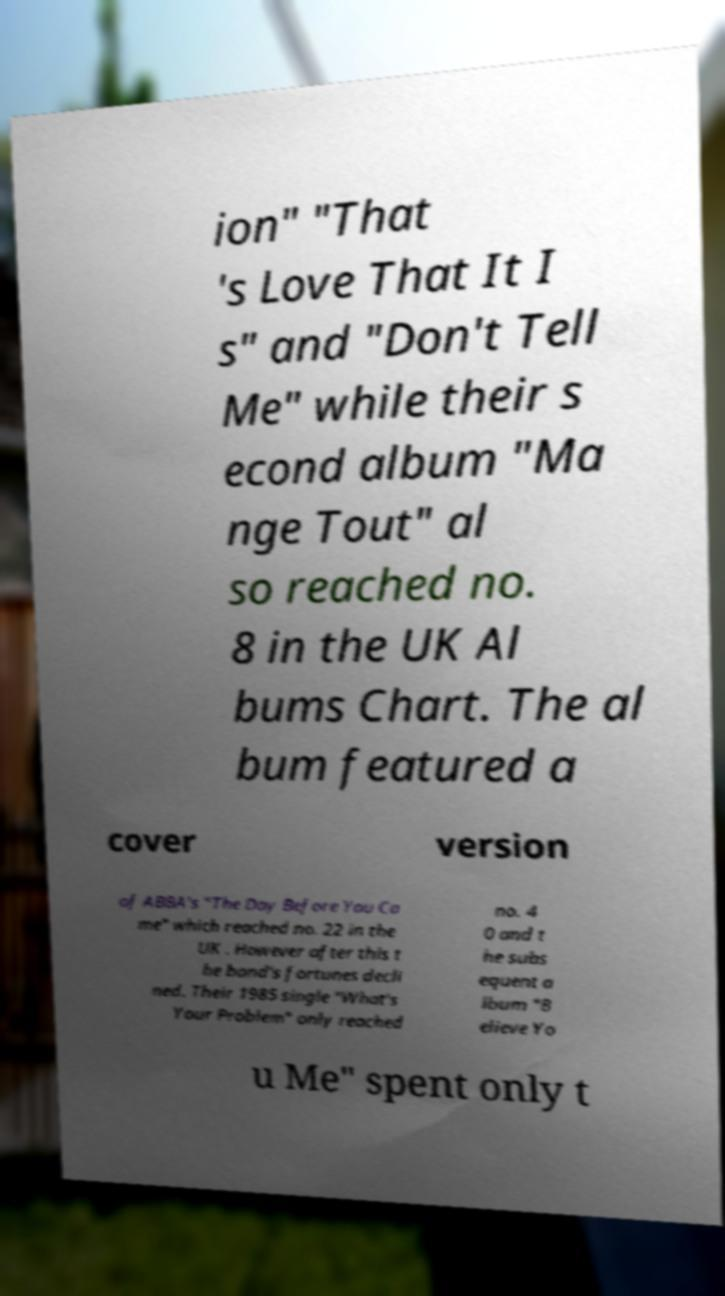Could you assist in decoding the text presented in this image and type it out clearly? ion" "That 's Love That It I s" and "Don't Tell Me" while their s econd album "Ma nge Tout" al so reached no. 8 in the UK Al bums Chart. The al bum featured a cover version of ABBA's "The Day Before You Ca me" which reached no. 22 in the UK . However after this t he band's fortunes decli ned. Their 1985 single "What's Your Problem" only reached no. 4 0 and t he subs equent a lbum "B elieve Yo u Me" spent only t 